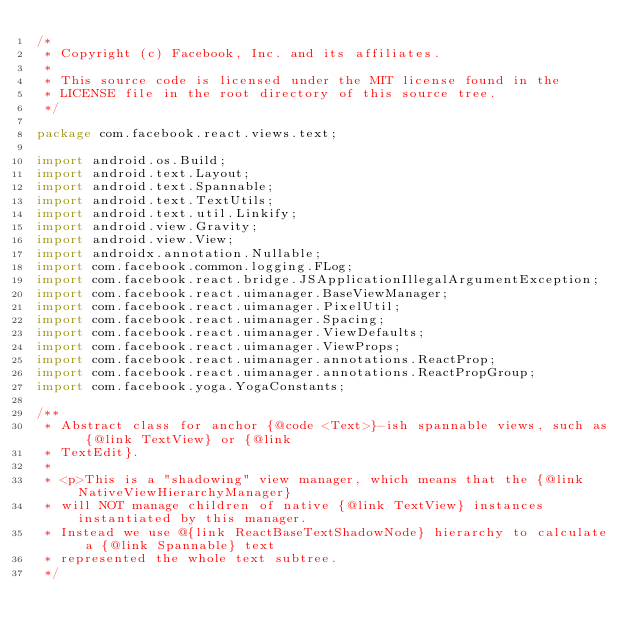<code> <loc_0><loc_0><loc_500><loc_500><_Java_>/*
 * Copyright (c) Facebook, Inc. and its affiliates.
 *
 * This source code is licensed under the MIT license found in the
 * LICENSE file in the root directory of this source tree.
 */

package com.facebook.react.views.text;

import android.os.Build;
import android.text.Layout;
import android.text.Spannable;
import android.text.TextUtils;
import android.text.util.Linkify;
import android.view.Gravity;
import android.view.View;
import androidx.annotation.Nullable;
import com.facebook.common.logging.FLog;
import com.facebook.react.bridge.JSApplicationIllegalArgumentException;
import com.facebook.react.uimanager.BaseViewManager;
import com.facebook.react.uimanager.PixelUtil;
import com.facebook.react.uimanager.Spacing;
import com.facebook.react.uimanager.ViewDefaults;
import com.facebook.react.uimanager.ViewProps;
import com.facebook.react.uimanager.annotations.ReactProp;
import com.facebook.react.uimanager.annotations.ReactPropGroup;
import com.facebook.yoga.YogaConstants;

/**
 * Abstract class for anchor {@code <Text>}-ish spannable views, such as {@link TextView} or {@link
 * TextEdit}.
 *
 * <p>This is a "shadowing" view manager, which means that the {@link NativeViewHierarchyManager}
 * will NOT manage children of native {@link TextView} instances instantiated by this manager.
 * Instead we use @{link ReactBaseTextShadowNode} hierarchy to calculate a {@link Spannable} text
 * represented the whole text subtree.
 */</code> 